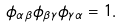Convert formula to latex. <formula><loc_0><loc_0><loc_500><loc_500>\phi _ { \alpha \beta } \phi _ { \beta \gamma } \phi _ { \gamma \alpha } = 1 .</formula> 